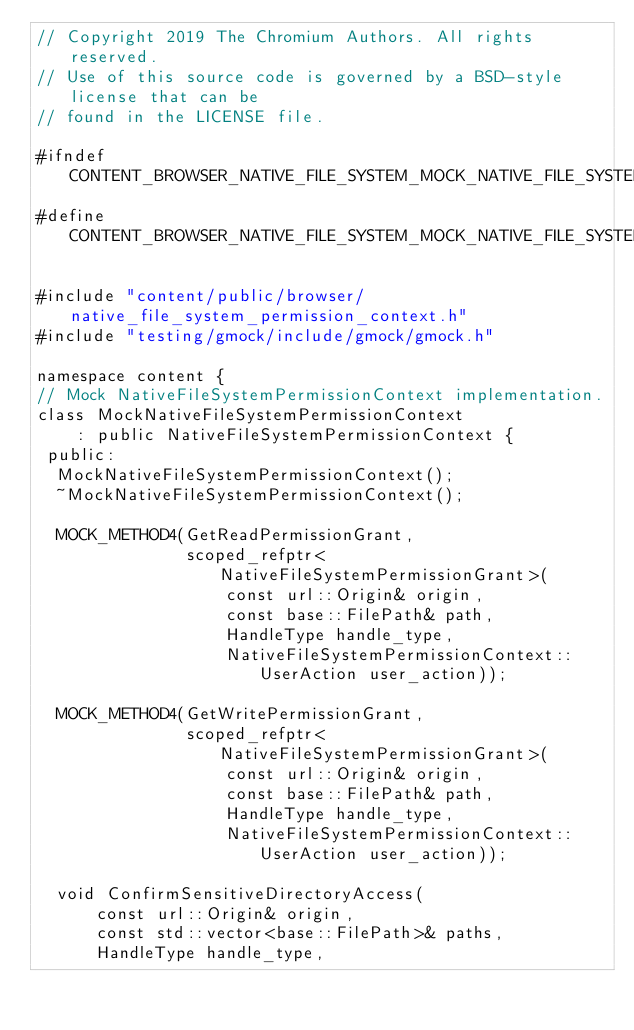Convert code to text. <code><loc_0><loc_0><loc_500><loc_500><_C_>// Copyright 2019 The Chromium Authors. All rights reserved.
// Use of this source code is governed by a BSD-style license that can be
// found in the LICENSE file.

#ifndef CONTENT_BROWSER_NATIVE_FILE_SYSTEM_MOCK_NATIVE_FILE_SYSTEM_PERMISSION_CONTEXT_H_
#define CONTENT_BROWSER_NATIVE_FILE_SYSTEM_MOCK_NATIVE_FILE_SYSTEM_PERMISSION_CONTEXT_H_

#include "content/public/browser/native_file_system_permission_context.h"
#include "testing/gmock/include/gmock/gmock.h"

namespace content {
// Mock NativeFileSystemPermissionContext implementation.
class MockNativeFileSystemPermissionContext
    : public NativeFileSystemPermissionContext {
 public:
  MockNativeFileSystemPermissionContext();
  ~MockNativeFileSystemPermissionContext();

  MOCK_METHOD4(GetReadPermissionGrant,
               scoped_refptr<NativeFileSystemPermissionGrant>(
                   const url::Origin& origin,
                   const base::FilePath& path,
                   HandleType handle_type,
                   NativeFileSystemPermissionContext::UserAction user_action));

  MOCK_METHOD4(GetWritePermissionGrant,
               scoped_refptr<NativeFileSystemPermissionGrant>(
                   const url::Origin& origin,
                   const base::FilePath& path,
                   HandleType handle_type,
                   NativeFileSystemPermissionContext::UserAction user_action));

  void ConfirmSensitiveDirectoryAccess(
      const url::Origin& origin,
      const std::vector<base::FilePath>& paths,
      HandleType handle_type,</code> 